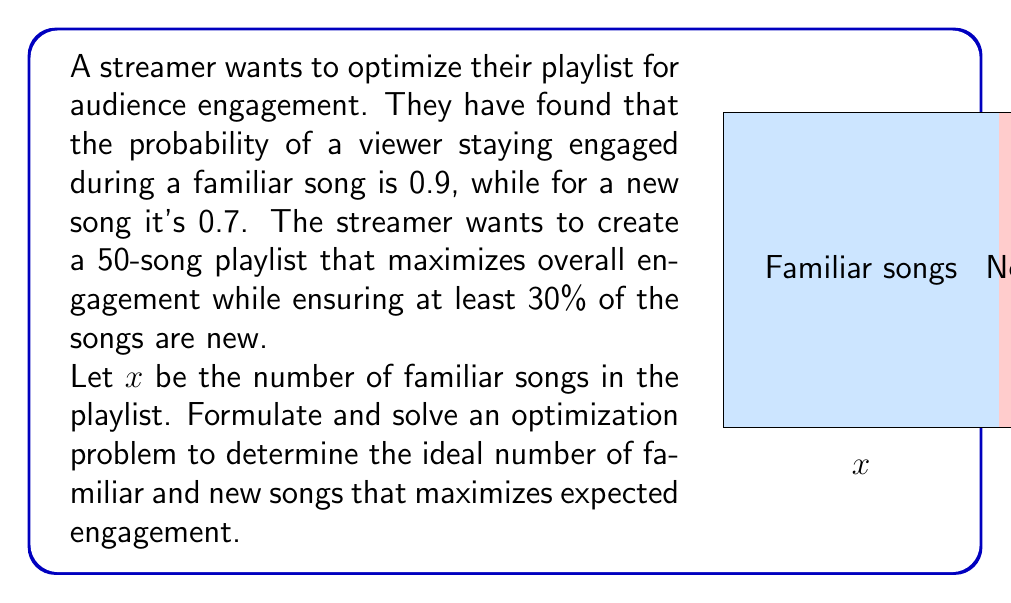Can you solve this math problem? Let's approach this step-by-step:

1) Define the objective function:
   The expected engagement is the sum of probabilities for each song type:
   $f(x) = 0.9x + 0.7(50-x)$

2) Define the constraints:
   - Total songs: $x + (50-x) = 50$
   - At least 30% new songs: $50-x \geq 0.3(50)$, which simplifies to $x \leq 35$
   - Non-negativity: $x \geq 0$

3) Simplify the objective function:
   $f(x) = 0.9x + 35 - 0.7x = 0.2x + 35$

4) The optimization problem becomes:
   Maximize $f(x) = 0.2x + 35$
   Subject to: $0 \leq x \leq 35$

5) Since the objective function is linear and increasing with x, the maximum will occur at the upper bound of x.

6) Therefore, the optimal solution is $x = 35$

7) This means:
   - Number of familiar songs: 35
   - Number of new songs: 50 - 35 = 15

8) The maximum expected engagement:
   $f(35) = 0.2(35) + 35 = 42$
Answer: 35 familiar songs, 15 new songs 